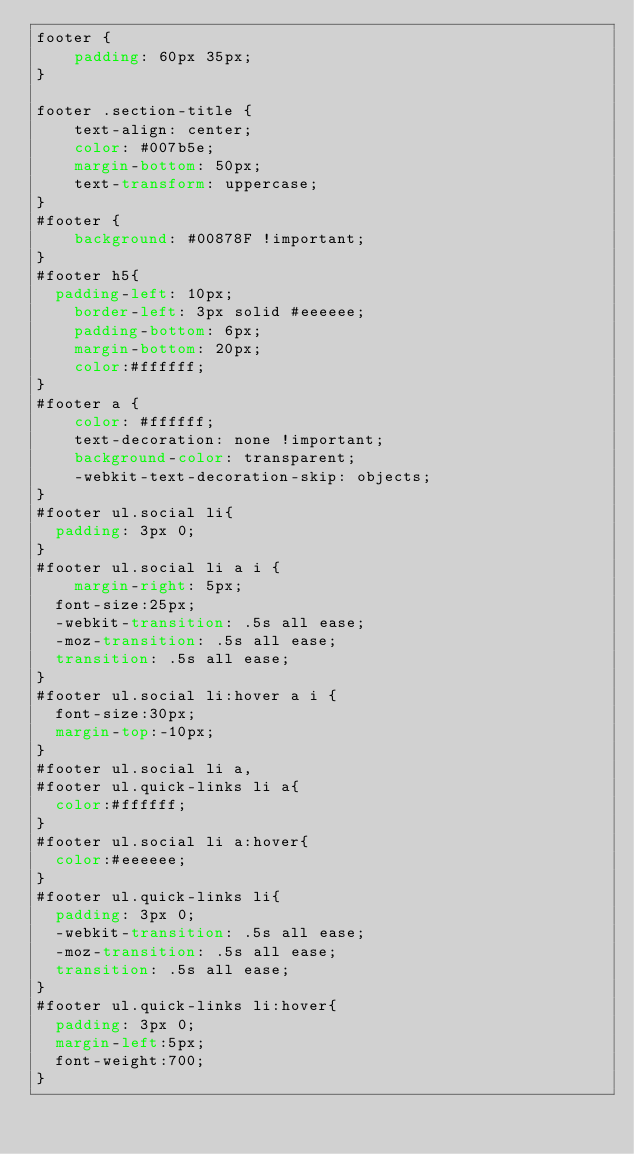Convert code to text. <code><loc_0><loc_0><loc_500><loc_500><_CSS_>footer {
    padding: 60px 35px;
}

footer .section-title {
    text-align: center;
    color: #007b5e;
    margin-bottom: 50px;
    text-transform: uppercase;
}
#footer {
    background: #00878F !important;
}
#footer h5{
	padding-left: 10px;
    border-left: 3px solid #eeeeee;
    padding-bottom: 6px;
    margin-bottom: 20px;
    color:#ffffff;
}
#footer a {
    color: #ffffff;
    text-decoration: none !important;
    background-color: transparent;
    -webkit-text-decoration-skip: objects;
}
#footer ul.social li{
	padding: 3px 0;
}
#footer ul.social li a i {
    margin-right: 5px;
	font-size:25px;
	-webkit-transition: .5s all ease;
	-moz-transition: .5s all ease;
	transition: .5s all ease;
}
#footer ul.social li:hover a i {
	font-size:30px;
	margin-top:-10px;
}
#footer ul.social li a,
#footer ul.quick-links li a{
	color:#ffffff;
}
#footer ul.social li a:hover{
	color:#eeeeee;
}
#footer ul.quick-links li{
	padding: 3px 0;
	-webkit-transition: .5s all ease;
	-moz-transition: .5s all ease;
	transition: .5s all ease;
}
#footer ul.quick-links li:hover{
	padding: 3px 0;
	margin-left:5px;
	font-weight:700;
}</code> 